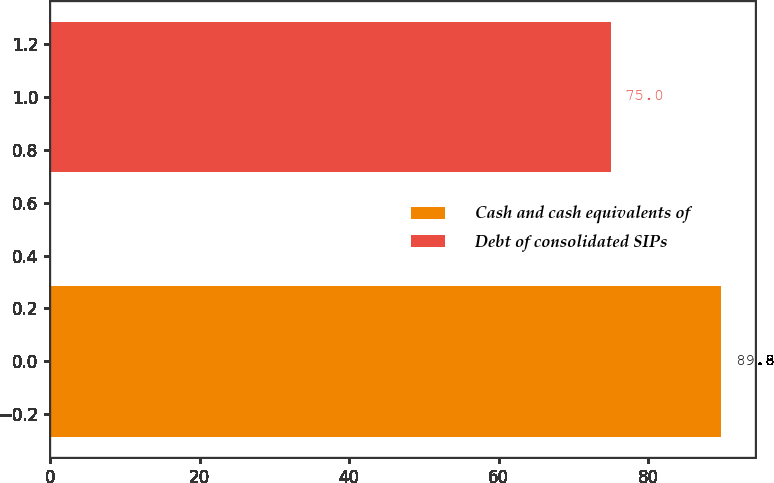Convert chart. <chart><loc_0><loc_0><loc_500><loc_500><bar_chart><fcel>Cash and cash equivalents of<fcel>Debt of consolidated SIPs<nl><fcel>89.8<fcel>75<nl></chart> 